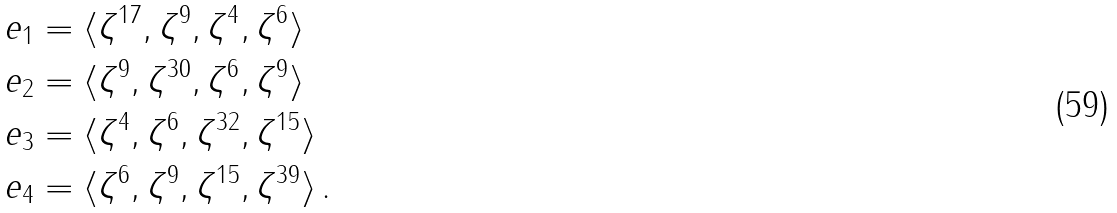<formula> <loc_0><loc_0><loc_500><loc_500>e _ { 1 } & = \langle \zeta ^ { 1 7 } , \zeta ^ { 9 } , \zeta ^ { 4 } , \zeta ^ { 6 } \rangle \\ e _ { 2 } & = \langle \zeta ^ { 9 } , \zeta ^ { 3 0 } , \zeta ^ { 6 } , \zeta ^ { 9 } \rangle \\ e _ { 3 } & = \langle \zeta ^ { 4 } , \zeta ^ { 6 } , \zeta ^ { 3 2 } , \zeta ^ { 1 5 } \rangle \\ e _ { 4 } & = \langle \zeta ^ { 6 } , \zeta ^ { 9 } , \zeta ^ { 1 5 } , \zeta ^ { 3 9 } \rangle \, .</formula> 